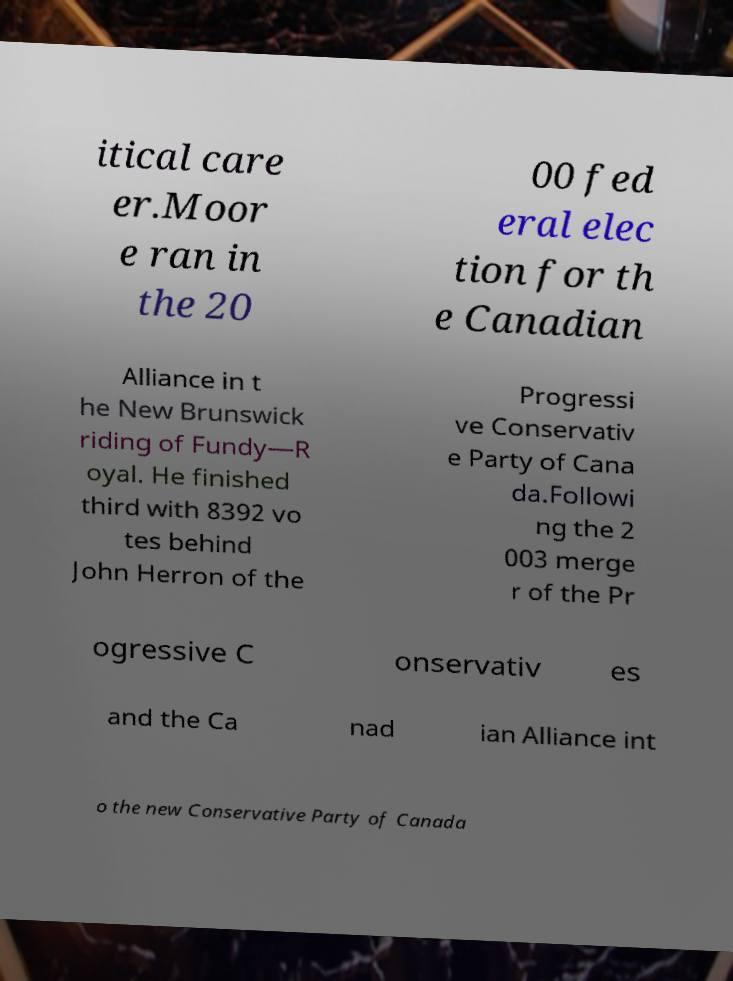What messages or text are displayed in this image? I need them in a readable, typed format. itical care er.Moor e ran in the 20 00 fed eral elec tion for th e Canadian Alliance in t he New Brunswick riding of Fundy—R oyal. He finished third with 8392 vo tes behind John Herron of the Progressi ve Conservativ e Party of Cana da.Followi ng the 2 003 merge r of the Pr ogressive C onservativ es and the Ca nad ian Alliance int o the new Conservative Party of Canada 